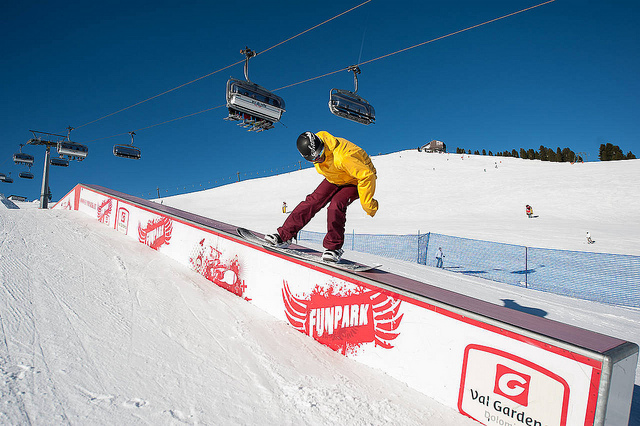<image>How fast is he going? I don't know how fast he is going. The speed could be estimated as 'fast', 'very fast', 'quite fast', or in mph. How fast is he going? I am not sure how fast he is going. It can be seen as fast, very fast or 45 mph. 